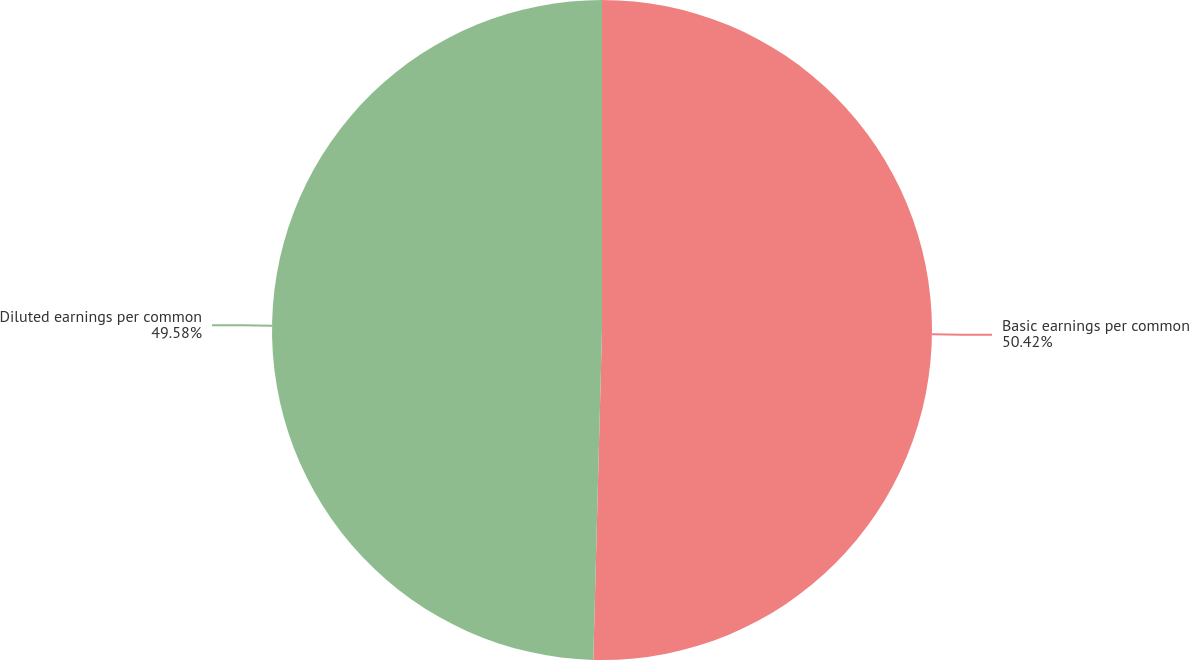<chart> <loc_0><loc_0><loc_500><loc_500><pie_chart><fcel>Basic earnings per common<fcel>Diluted earnings per common<nl><fcel>50.42%<fcel>49.58%<nl></chart> 